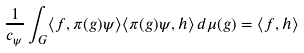Convert formula to latex. <formula><loc_0><loc_0><loc_500><loc_500>\frac { 1 } { c _ { \psi } } \int _ { G } \langle f , \pi ( g ) \psi \rangle \langle \pi ( g ) \psi , h \rangle \, d \mu ( g ) = \langle f , h \rangle</formula> 